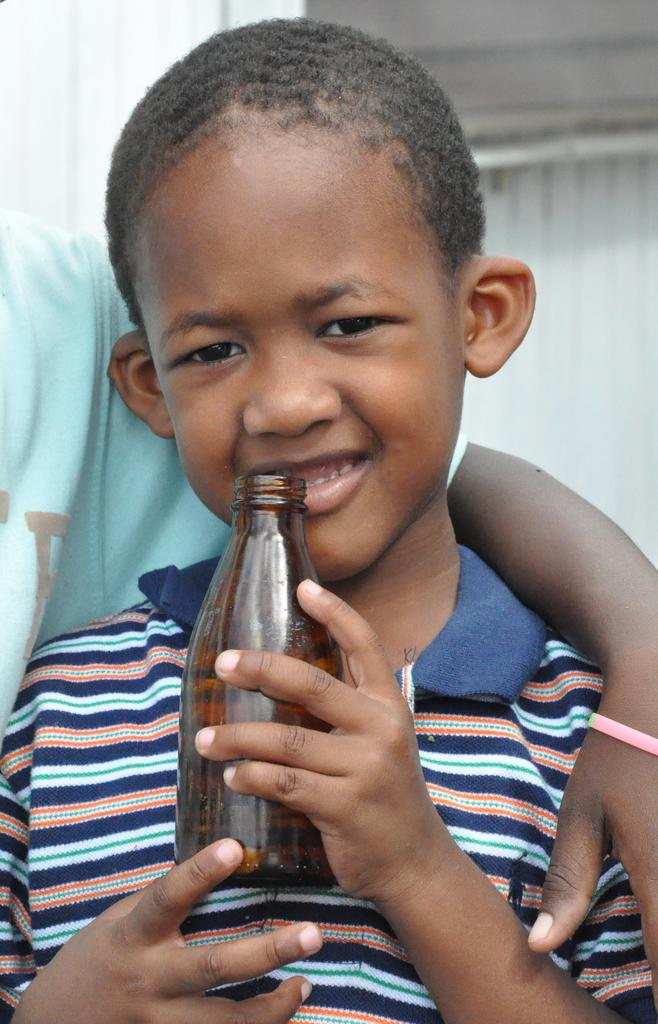What is the main subject of the image? The main subject of the image is a kid. What is the kid holding in the image? The kid is holding a bottle in the image. Can you describe the relationship between the kid and the other person in the image? The second person is standing beside the kid and has their hand on the kid's shoulder. What type of harmony is being played by the horn in the image? There is no horn present in the image, so it is not possible to determine what type of harmony might be played. 